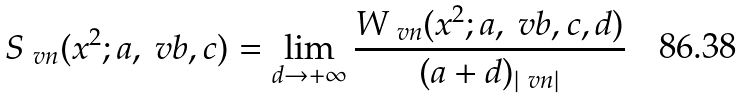<formula> <loc_0><loc_0><loc_500><loc_500>S _ { \ v n } ( x ^ { 2 } ; a , \ v b , c ) = \lim _ { d \to + \infty } \frac { W _ { \ v n } ( x ^ { 2 } ; a , \ v b , c , d ) } { ( a + d ) _ { | \ v n | } }</formula> 